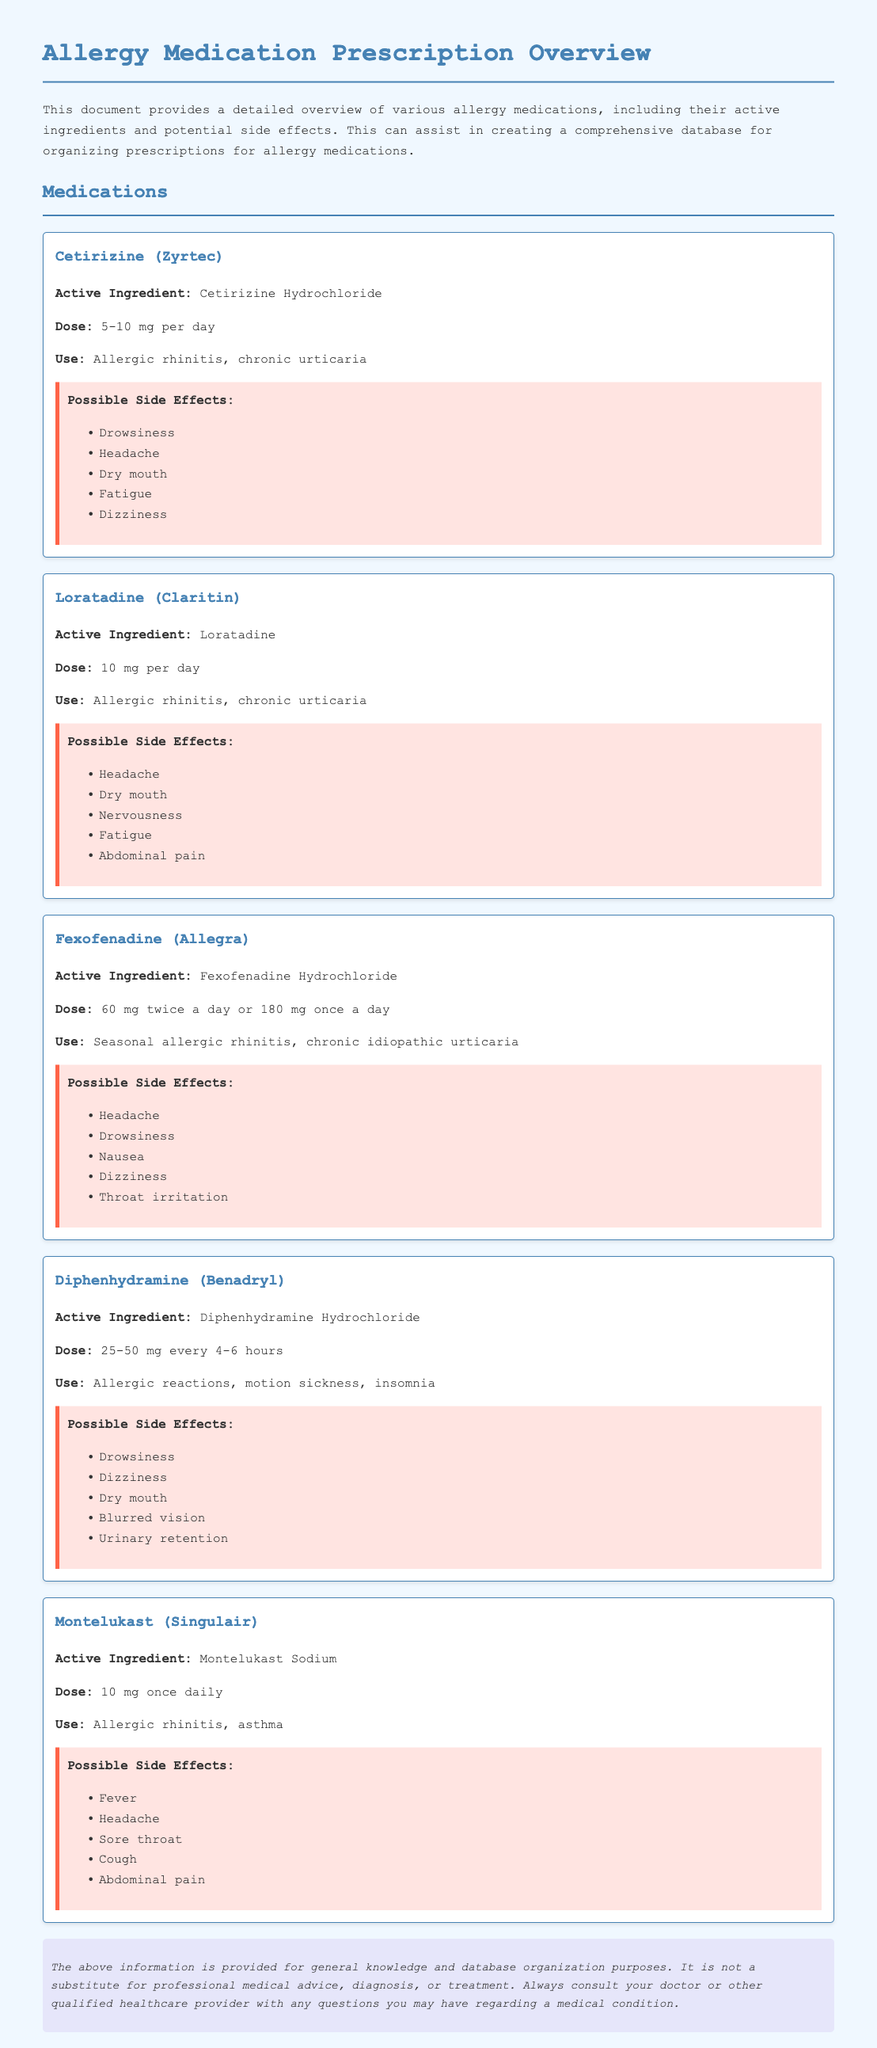What is the active ingredient in Zyrtec? The active ingredient in Zyrtec is Cetirizine Hydrochloride.
Answer: Cetirizine Hydrochloride How often should Fexofenadine be taken? Fexofenadine can be taken either 60 mg twice a day or 180 mg once a day.
Answer: Twice a day or once a day What is the recommended dose for Claritin? The recommended dose for Claritin is 10 mg per day.
Answer: 10 mg What are the possible side effects of Diphenhydramine? The possible side effects of Diphenhydramine include drowsiness, dizziness, dry mouth, blurred vision, and urinary retention.
Answer: Drowsiness, dizziness, dry mouth, blurred vision, urinary retention Which medication is used for asthma? Montelukast is used for asthma.
Answer: Montelukast Identify one side effect common to both Cetirizine and Diphenhydramine. Both Cetirizine and Diphenhydramine list drowsiness as a side effect.
Answer: Drowsiness How does Fexofenadine differ in use compared to Cetirizine? Fexofenadine is used for seasonal allergic rhinitis whereas Cetirizine is for allergic rhinitis and chronic urticaria.
Answer: Seasonal allergic rhinitis What document type is this? This document provides information on allergy medications and their prescriptions.
Answer: Prescription What is included in the disclaimer section? The disclaimer section states that the information is not a substitute for professional medical advice and encourages consultation with a healthcare provider.
Answer: Not a substitute for medical advice 